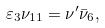<formula> <loc_0><loc_0><loc_500><loc_500>\varepsilon _ { 3 } \nu _ { 1 1 } = \nu ^ { \prime } \bar { \nu } _ { 6 } ,</formula> 